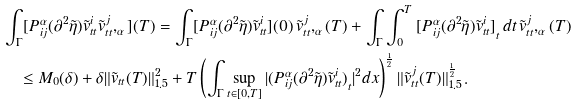Convert formula to latex. <formula><loc_0><loc_0><loc_500><loc_500>& \int _ { \Gamma } [ P ^ { \alpha } _ { i j } ( \partial ^ { 2 } \tilde { \eta } ) \tilde { v } ^ { i } _ { t t } \tilde { v } ^ { j } _ { t t } , _ { \alpha } ] ( T ) = \int _ { \Gamma } [ P ^ { \alpha } _ { i j } ( \partial ^ { 2 } \tilde { \eta } ) \tilde { v } ^ { i } _ { t t } ] ( 0 ) \, \tilde { v } ^ { j } _ { t t } , _ { \alpha } ( T ) + \int _ { \Gamma } \int _ { 0 } ^ { T } { [ P ^ { \alpha } _ { i j } ( \partial ^ { 2 } \tilde { \eta } ) \tilde { v } ^ { i } _ { t t } ] } _ { t } \, d t \, \tilde { v } ^ { j } _ { t t } , _ { \alpha } ( T ) \\ & \quad \leq M _ { 0 } ( \delta ) + \delta \| \tilde { v } _ { t t } ( T ) \| _ { 1 . 5 } ^ { 2 } + T \left ( \int _ { \Gamma } \sup _ { t \in [ 0 , T ] } | { ( P ^ { \alpha } _ { i j } ( \partial ^ { 2 } \tilde { \eta } ) \tilde { v } ^ { i } _ { t t } ) } _ { t } | ^ { 2 } d x \right ) ^ { \frac { 1 } { 2 } } \| \tilde { v } ^ { j } _ { t t } ( T ) \| _ { 1 . 5 } ^ { \frac { 1 } { 2 } } \, .</formula> 